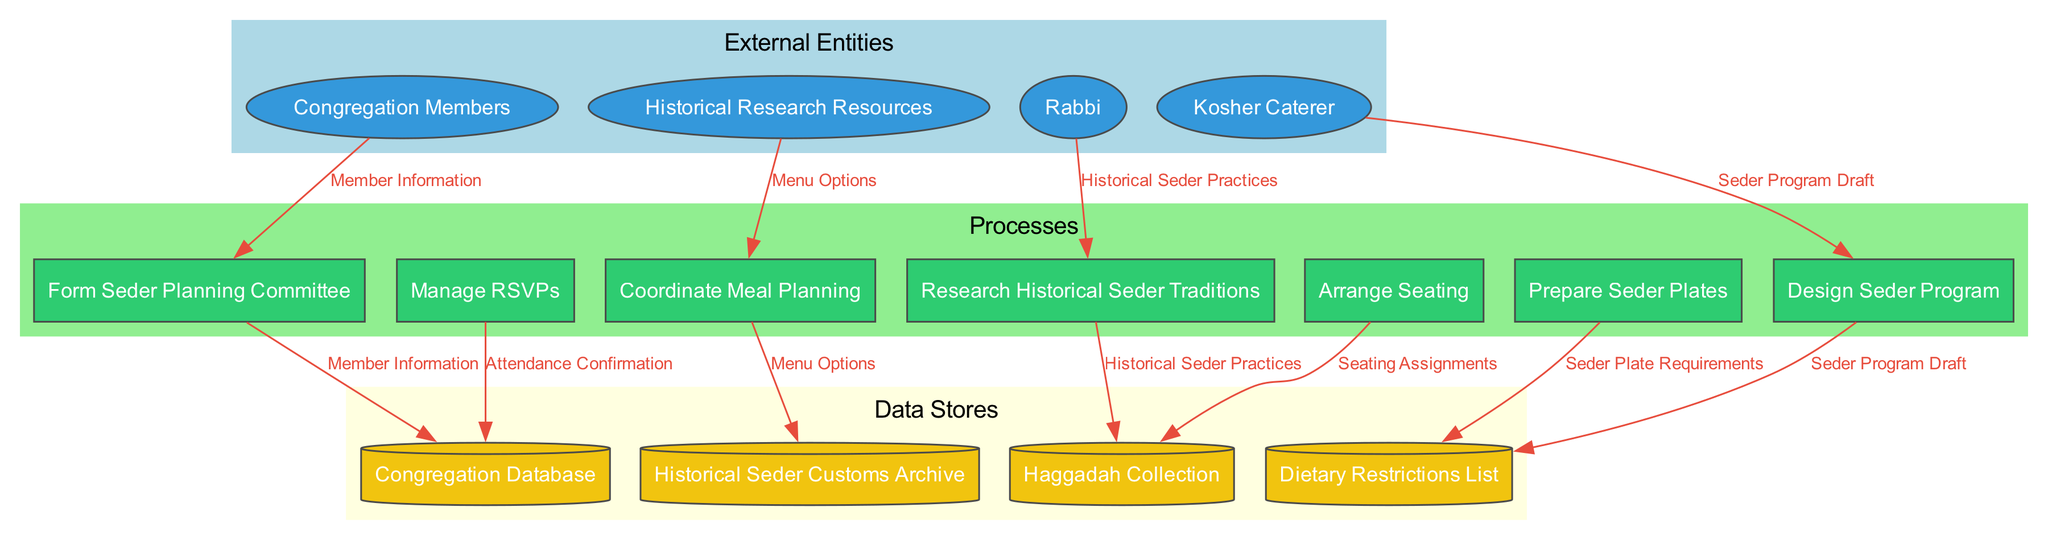What are the external entities in this diagram? The external entities are listed under the "External Entities" section of the diagram. They include "Congregation Members," "Rabbi," "Kosher Caterer," and "Historical Research Resources."
Answer: Congregation Members, Rabbi, Kosher Caterer, Historical Research Resources How many processes are represented in the diagram? To find the number of processes, we count the items listed under "Processes." There are a total of seven processes.
Answer: 7 Which data store is linked to the "Manage RSVPs" process? We follow the data flow from the "Manage RSVPs" process to the data store it connects to. The process is linked to the "Congregation Database" data store.
Answer: Congregation Database What type of data flows from "Congregation Members" to "Form Seder Planning Committee"? This flow can be identified by examining the connection in the diagram. The data flow from "Congregation Members" to "Form Seder Planning Committee" consists of "Member Information."
Answer: Member Information How many data stores are identified in the diagram? We count the entries listed under "Data Stores" in the diagram to determine the number. There are four data stores present.
Answer: 4 Which process is reliant on "Historical Seder Practices"? By tracing the data flow, we see that "Research Historical Seder Traditions" utilizes "Historical Seder Practices" as input.
Answer: Research Historical Seder Traditions What is the output of the "Design Seder Program" process? The output can be found by looking at the data flow that leaves the "Design Seder Program" process. It produces the "Seder Program Draft."
Answer: Seder Program Draft Which process leads to the "Seating Assignments"? To find out which process results in "Seating Assignments," we analyze the data flow connections. The "Arrange Seating" process provides this output.
Answer: Arrange Seating Which external entity interacts with the "Kosher Caterer"? The "Kosher Caterer" is connected to the planning processes related to meal preparation. The external entity interacting with it is "Rabbi."
Answer: Rabbi 